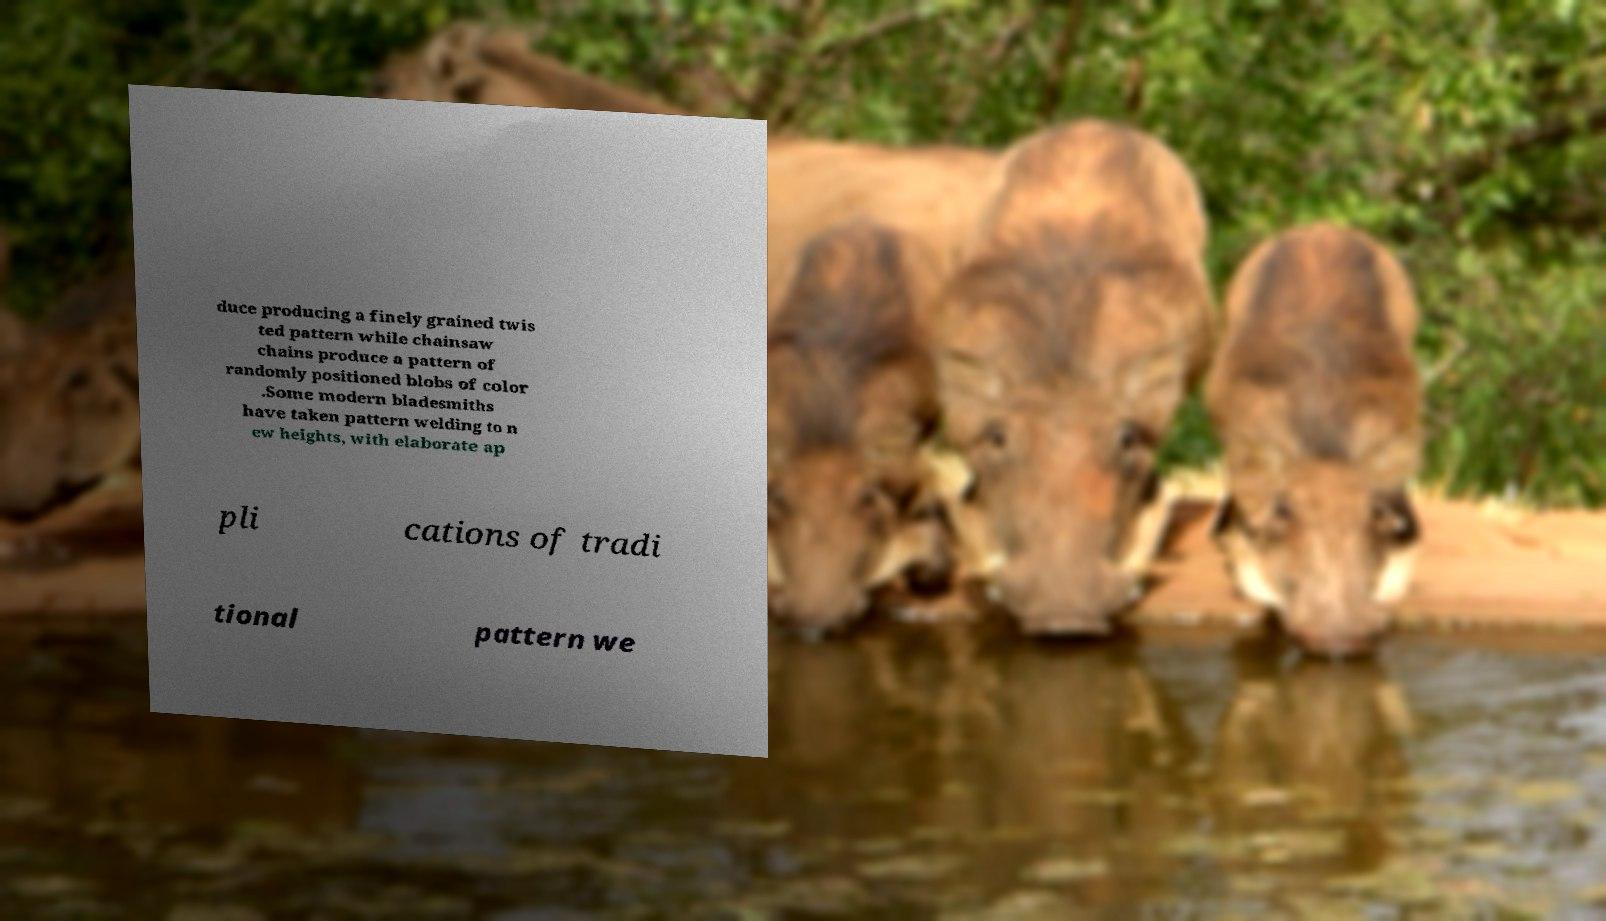Could you assist in decoding the text presented in this image and type it out clearly? duce producing a finely grained twis ted pattern while chainsaw chains produce a pattern of randomly positioned blobs of color .Some modern bladesmiths have taken pattern welding to n ew heights, with elaborate ap pli cations of tradi tional pattern we 